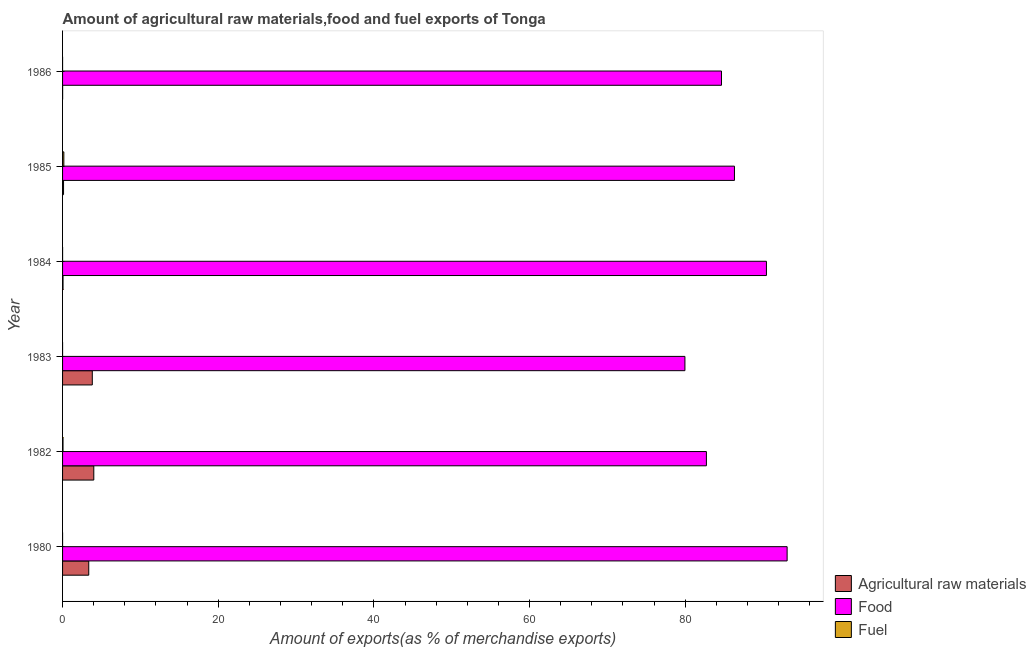Are the number of bars on each tick of the Y-axis equal?
Ensure brevity in your answer.  Yes. How many bars are there on the 6th tick from the bottom?
Keep it short and to the point. 3. In how many cases, is the number of bars for a given year not equal to the number of legend labels?
Offer a very short reply. 0. What is the percentage of fuel exports in 1984?
Provide a succinct answer. 0. Across all years, what is the maximum percentage of fuel exports?
Keep it short and to the point. 0.16. Across all years, what is the minimum percentage of food exports?
Ensure brevity in your answer.  79.96. What is the total percentage of fuel exports in the graph?
Make the answer very short. 0.22. What is the difference between the percentage of food exports in 1982 and that in 1984?
Give a very brief answer. -7.71. What is the difference between the percentage of fuel exports in 1985 and the percentage of raw materials exports in 1986?
Make the answer very short. 0.16. What is the average percentage of food exports per year?
Offer a terse response. 86.19. In the year 1983, what is the difference between the percentage of fuel exports and percentage of raw materials exports?
Your answer should be very brief. -3.82. In how many years, is the percentage of food exports greater than 40 %?
Give a very brief answer. 6. What is the ratio of the percentage of fuel exports in 1982 to that in 1986?
Provide a short and direct response. 410.56. Is the difference between the percentage of fuel exports in 1983 and 1985 greater than the difference between the percentage of raw materials exports in 1983 and 1985?
Make the answer very short. No. What is the difference between the highest and the second highest percentage of fuel exports?
Provide a succinct answer. 0.11. What is the difference between the highest and the lowest percentage of food exports?
Give a very brief answer. 13.13. Is the sum of the percentage of food exports in 1983 and 1986 greater than the maximum percentage of raw materials exports across all years?
Keep it short and to the point. Yes. What does the 2nd bar from the top in 1982 represents?
Offer a very short reply. Food. What does the 1st bar from the bottom in 1980 represents?
Your answer should be compact. Agricultural raw materials. Is it the case that in every year, the sum of the percentage of raw materials exports and percentage of food exports is greater than the percentage of fuel exports?
Keep it short and to the point. Yes. How many bars are there?
Your answer should be very brief. 18. What is the difference between two consecutive major ticks on the X-axis?
Your response must be concise. 20. Does the graph contain any zero values?
Make the answer very short. No. How are the legend labels stacked?
Your response must be concise. Vertical. What is the title of the graph?
Your answer should be very brief. Amount of agricultural raw materials,food and fuel exports of Tonga. What is the label or title of the X-axis?
Keep it short and to the point. Amount of exports(as % of merchandise exports). What is the label or title of the Y-axis?
Provide a short and direct response. Year. What is the Amount of exports(as % of merchandise exports) in Agricultural raw materials in 1980?
Ensure brevity in your answer.  3.36. What is the Amount of exports(as % of merchandise exports) in Food in 1980?
Your answer should be very brief. 93.09. What is the Amount of exports(as % of merchandise exports) in Fuel in 1980?
Give a very brief answer. 0. What is the Amount of exports(as % of merchandise exports) in Agricultural raw materials in 1982?
Keep it short and to the point. 4.01. What is the Amount of exports(as % of merchandise exports) of Food in 1982?
Your response must be concise. 82.72. What is the Amount of exports(as % of merchandise exports) in Fuel in 1982?
Your answer should be very brief. 0.06. What is the Amount of exports(as % of merchandise exports) of Agricultural raw materials in 1983?
Give a very brief answer. 3.82. What is the Amount of exports(as % of merchandise exports) in Food in 1983?
Provide a short and direct response. 79.96. What is the Amount of exports(as % of merchandise exports) of Fuel in 1983?
Give a very brief answer. 0. What is the Amount of exports(as % of merchandise exports) of Agricultural raw materials in 1984?
Make the answer very short. 0.06. What is the Amount of exports(as % of merchandise exports) of Food in 1984?
Provide a succinct answer. 90.43. What is the Amount of exports(as % of merchandise exports) in Fuel in 1984?
Ensure brevity in your answer.  0. What is the Amount of exports(as % of merchandise exports) in Agricultural raw materials in 1985?
Ensure brevity in your answer.  0.13. What is the Amount of exports(as % of merchandise exports) in Food in 1985?
Ensure brevity in your answer.  86.32. What is the Amount of exports(as % of merchandise exports) in Fuel in 1985?
Make the answer very short. 0.16. What is the Amount of exports(as % of merchandise exports) in Agricultural raw materials in 1986?
Ensure brevity in your answer.  0.01. What is the Amount of exports(as % of merchandise exports) in Food in 1986?
Make the answer very short. 84.65. What is the Amount of exports(as % of merchandise exports) in Fuel in 1986?
Your answer should be very brief. 0. Across all years, what is the maximum Amount of exports(as % of merchandise exports) of Agricultural raw materials?
Offer a terse response. 4.01. Across all years, what is the maximum Amount of exports(as % of merchandise exports) of Food?
Make the answer very short. 93.09. Across all years, what is the maximum Amount of exports(as % of merchandise exports) in Fuel?
Your answer should be very brief. 0.16. Across all years, what is the minimum Amount of exports(as % of merchandise exports) in Agricultural raw materials?
Give a very brief answer. 0.01. Across all years, what is the minimum Amount of exports(as % of merchandise exports) of Food?
Offer a terse response. 79.96. Across all years, what is the minimum Amount of exports(as % of merchandise exports) of Fuel?
Your answer should be compact. 0. What is the total Amount of exports(as % of merchandise exports) in Agricultural raw materials in the graph?
Keep it short and to the point. 11.39. What is the total Amount of exports(as % of merchandise exports) in Food in the graph?
Provide a succinct answer. 517.17. What is the total Amount of exports(as % of merchandise exports) in Fuel in the graph?
Ensure brevity in your answer.  0.22. What is the difference between the Amount of exports(as % of merchandise exports) in Agricultural raw materials in 1980 and that in 1982?
Provide a succinct answer. -0.65. What is the difference between the Amount of exports(as % of merchandise exports) in Food in 1980 and that in 1982?
Provide a succinct answer. 10.37. What is the difference between the Amount of exports(as % of merchandise exports) of Fuel in 1980 and that in 1982?
Your response must be concise. -0.06. What is the difference between the Amount of exports(as % of merchandise exports) of Agricultural raw materials in 1980 and that in 1983?
Make the answer very short. -0.46. What is the difference between the Amount of exports(as % of merchandise exports) of Food in 1980 and that in 1983?
Your response must be concise. 13.13. What is the difference between the Amount of exports(as % of merchandise exports) of Fuel in 1980 and that in 1983?
Give a very brief answer. -0. What is the difference between the Amount of exports(as % of merchandise exports) in Agricultural raw materials in 1980 and that in 1984?
Offer a terse response. 3.3. What is the difference between the Amount of exports(as % of merchandise exports) in Food in 1980 and that in 1984?
Give a very brief answer. 2.66. What is the difference between the Amount of exports(as % of merchandise exports) of Fuel in 1980 and that in 1984?
Give a very brief answer. -0. What is the difference between the Amount of exports(as % of merchandise exports) of Agricultural raw materials in 1980 and that in 1985?
Provide a short and direct response. 3.24. What is the difference between the Amount of exports(as % of merchandise exports) in Food in 1980 and that in 1985?
Give a very brief answer. 6.77. What is the difference between the Amount of exports(as % of merchandise exports) of Fuel in 1980 and that in 1985?
Provide a succinct answer. -0.16. What is the difference between the Amount of exports(as % of merchandise exports) in Agricultural raw materials in 1980 and that in 1986?
Ensure brevity in your answer.  3.36. What is the difference between the Amount of exports(as % of merchandise exports) of Food in 1980 and that in 1986?
Keep it short and to the point. 8.43. What is the difference between the Amount of exports(as % of merchandise exports) of Agricultural raw materials in 1982 and that in 1983?
Keep it short and to the point. 0.19. What is the difference between the Amount of exports(as % of merchandise exports) of Food in 1982 and that in 1983?
Make the answer very short. 2.76. What is the difference between the Amount of exports(as % of merchandise exports) in Fuel in 1982 and that in 1983?
Ensure brevity in your answer.  0.06. What is the difference between the Amount of exports(as % of merchandise exports) in Agricultural raw materials in 1982 and that in 1984?
Provide a succinct answer. 3.95. What is the difference between the Amount of exports(as % of merchandise exports) in Food in 1982 and that in 1984?
Ensure brevity in your answer.  -7.71. What is the difference between the Amount of exports(as % of merchandise exports) in Fuel in 1982 and that in 1984?
Provide a short and direct response. 0.06. What is the difference between the Amount of exports(as % of merchandise exports) of Agricultural raw materials in 1982 and that in 1985?
Keep it short and to the point. 3.89. What is the difference between the Amount of exports(as % of merchandise exports) in Food in 1982 and that in 1985?
Offer a terse response. -3.6. What is the difference between the Amount of exports(as % of merchandise exports) of Fuel in 1982 and that in 1985?
Keep it short and to the point. -0.11. What is the difference between the Amount of exports(as % of merchandise exports) in Agricultural raw materials in 1982 and that in 1986?
Provide a succinct answer. 4. What is the difference between the Amount of exports(as % of merchandise exports) in Food in 1982 and that in 1986?
Make the answer very short. -1.94. What is the difference between the Amount of exports(as % of merchandise exports) in Fuel in 1982 and that in 1986?
Your answer should be very brief. 0.06. What is the difference between the Amount of exports(as % of merchandise exports) in Agricultural raw materials in 1983 and that in 1984?
Ensure brevity in your answer.  3.76. What is the difference between the Amount of exports(as % of merchandise exports) of Food in 1983 and that in 1984?
Your response must be concise. -10.47. What is the difference between the Amount of exports(as % of merchandise exports) in Fuel in 1983 and that in 1984?
Provide a succinct answer. -0. What is the difference between the Amount of exports(as % of merchandise exports) in Agricultural raw materials in 1983 and that in 1985?
Give a very brief answer. 3.7. What is the difference between the Amount of exports(as % of merchandise exports) of Food in 1983 and that in 1985?
Your response must be concise. -6.36. What is the difference between the Amount of exports(as % of merchandise exports) of Fuel in 1983 and that in 1985?
Provide a succinct answer. -0.16. What is the difference between the Amount of exports(as % of merchandise exports) in Agricultural raw materials in 1983 and that in 1986?
Your answer should be very brief. 3.81. What is the difference between the Amount of exports(as % of merchandise exports) of Food in 1983 and that in 1986?
Ensure brevity in your answer.  -4.7. What is the difference between the Amount of exports(as % of merchandise exports) of Agricultural raw materials in 1984 and that in 1985?
Your answer should be very brief. -0.07. What is the difference between the Amount of exports(as % of merchandise exports) in Food in 1984 and that in 1985?
Provide a succinct answer. 4.11. What is the difference between the Amount of exports(as % of merchandise exports) of Fuel in 1984 and that in 1985?
Provide a succinct answer. -0.16. What is the difference between the Amount of exports(as % of merchandise exports) in Agricultural raw materials in 1984 and that in 1986?
Provide a succinct answer. 0.05. What is the difference between the Amount of exports(as % of merchandise exports) in Food in 1984 and that in 1986?
Your answer should be very brief. 5.78. What is the difference between the Amount of exports(as % of merchandise exports) in Fuel in 1984 and that in 1986?
Keep it short and to the point. 0. What is the difference between the Amount of exports(as % of merchandise exports) in Agricultural raw materials in 1985 and that in 1986?
Make the answer very short. 0.12. What is the difference between the Amount of exports(as % of merchandise exports) of Food in 1985 and that in 1986?
Your response must be concise. 1.67. What is the difference between the Amount of exports(as % of merchandise exports) of Fuel in 1985 and that in 1986?
Ensure brevity in your answer.  0.16. What is the difference between the Amount of exports(as % of merchandise exports) in Agricultural raw materials in 1980 and the Amount of exports(as % of merchandise exports) in Food in 1982?
Your answer should be compact. -79.35. What is the difference between the Amount of exports(as % of merchandise exports) in Agricultural raw materials in 1980 and the Amount of exports(as % of merchandise exports) in Fuel in 1982?
Offer a terse response. 3.31. What is the difference between the Amount of exports(as % of merchandise exports) of Food in 1980 and the Amount of exports(as % of merchandise exports) of Fuel in 1982?
Provide a short and direct response. 93.03. What is the difference between the Amount of exports(as % of merchandise exports) in Agricultural raw materials in 1980 and the Amount of exports(as % of merchandise exports) in Food in 1983?
Provide a succinct answer. -76.59. What is the difference between the Amount of exports(as % of merchandise exports) of Agricultural raw materials in 1980 and the Amount of exports(as % of merchandise exports) of Fuel in 1983?
Make the answer very short. 3.36. What is the difference between the Amount of exports(as % of merchandise exports) in Food in 1980 and the Amount of exports(as % of merchandise exports) in Fuel in 1983?
Offer a terse response. 93.09. What is the difference between the Amount of exports(as % of merchandise exports) in Agricultural raw materials in 1980 and the Amount of exports(as % of merchandise exports) in Food in 1984?
Offer a very short reply. -87.07. What is the difference between the Amount of exports(as % of merchandise exports) in Agricultural raw materials in 1980 and the Amount of exports(as % of merchandise exports) in Fuel in 1984?
Your answer should be very brief. 3.36. What is the difference between the Amount of exports(as % of merchandise exports) in Food in 1980 and the Amount of exports(as % of merchandise exports) in Fuel in 1984?
Keep it short and to the point. 93.09. What is the difference between the Amount of exports(as % of merchandise exports) in Agricultural raw materials in 1980 and the Amount of exports(as % of merchandise exports) in Food in 1985?
Your answer should be compact. -82.96. What is the difference between the Amount of exports(as % of merchandise exports) in Agricultural raw materials in 1980 and the Amount of exports(as % of merchandise exports) in Fuel in 1985?
Your answer should be very brief. 3.2. What is the difference between the Amount of exports(as % of merchandise exports) in Food in 1980 and the Amount of exports(as % of merchandise exports) in Fuel in 1985?
Provide a short and direct response. 92.92. What is the difference between the Amount of exports(as % of merchandise exports) of Agricultural raw materials in 1980 and the Amount of exports(as % of merchandise exports) of Food in 1986?
Offer a very short reply. -81.29. What is the difference between the Amount of exports(as % of merchandise exports) in Agricultural raw materials in 1980 and the Amount of exports(as % of merchandise exports) in Fuel in 1986?
Offer a very short reply. 3.36. What is the difference between the Amount of exports(as % of merchandise exports) of Food in 1980 and the Amount of exports(as % of merchandise exports) of Fuel in 1986?
Your answer should be compact. 93.09. What is the difference between the Amount of exports(as % of merchandise exports) in Agricultural raw materials in 1982 and the Amount of exports(as % of merchandise exports) in Food in 1983?
Ensure brevity in your answer.  -75.95. What is the difference between the Amount of exports(as % of merchandise exports) in Agricultural raw materials in 1982 and the Amount of exports(as % of merchandise exports) in Fuel in 1983?
Offer a terse response. 4.01. What is the difference between the Amount of exports(as % of merchandise exports) of Food in 1982 and the Amount of exports(as % of merchandise exports) of Fuel in 1983?
Your answer should be very brief. 82.72. What is the difference between the Amount of exports(as % of merchandise exports) in Agricultural raw materials in 1982 and the Amount of exports(as % of merchandise exports) in Food in 1984?
Offer a terse response. -86.42. What is the difference between the Amount of exports(as % of merchandise exports) in Agricultural raw materials in 1982 and the Amount of exports(as % of merchandise exports) in Fuel in 1984?
Your response must be concise. 4.01. What is the difference between the Amount of exports(as % of merchandise exports) of Food in 1982 and the Amount of exports(as % of merchandise exports) of Fuel in 1984?
Offer a terse response. 82.72. What is the difference between the Amount of exports(as % of merchandise exports) of Agricultural raw materials in 1982 and the Amount of exports(as % of merchandise exports) of Food in 1985?
Provide a succinct answer. -82.31. What is the difference between the Amount of exports(as % of merchandise exports) of Agricultural raw materials in 1982 and the Amount of exports(as % of merchandise exports) of Fuel in 1985?
Offer a terse response. 3.85. What is the difference between the Amount of exports(as % of merchandise exports) in Food in 1982 and the Amount of exports(as % of merchandise exports) in Fuel in 1985?
Make the answer very short. 82.55. What is the difference between the Amount of exports(as % of merchandise exports) in Agricultural raw materials in 1982 and the Amount of exports(as % of merchandise exports) in Food in 1986?
Offer a very short reply. -80.64. What is the difference between the Amount of exports(as % of merchandise exports) of Agricultural raw materials in 1982 and the Amount of exports(as % of merchandise exports) of Fuel in 1986?
Offer a very short reply. 4.01. What is the difference between the Amount of exports(as % of merchandise exports) of Food in 1982 and the Amount of exports(as % of merchandise exports) of Fuel in 1986?
Keep it short and to the point. 82.72. What is the difference between the Amount of exports(as % of merchandise exports) of Agricultural raw materials in 1983 and the Amount of exports(as % of merchandise exports) of Food in 1984?
Your answer should be compact. -86.61. What is the difference between the Amount of exports(as % of merchandise exports) of Agricultural raw materials in 1983 and the Amount of exports(as % of merchandise exports) of Fuel in 1984?
Your answer should be compact. 3.82. What is the difference between the Amount of exports(as % of merchandise exports) in Food in 1983 and the Amount of exports(as % of merchandise exports) in Fuel in 1984?
Ensure brevity in your answer.  79.96. What is the difference between the Amount of exports(as % of merchandise exports) in Agricultural raw materials in 1983 and the Amount of exports(as % of merchandise exports) in Food in 1985?
Ensure brevity in your answer.  -82.5. What is the difference between the Amount of exports(as % of merchandise exports) of Agricultural raw materials in 1983 and the Amount of exports(as % of merchandise exports) of Fuel in 1985?
Your answer should be very brief. 3.66. What is the difference between the Amount of exports(as % of merchandise exports) of Food in 1983 and the Amount of exports(as % of merchandise exports) of Fuel in 1985?
Your answer should be very brief. 79.79. What is the difference between the Amount of exports(as % of merchandise exports) of Agricultural raw materials in 1983 and the Amount of exports(as % of merchandise exports) of Food in 1986?
Provide a short and direct response. -80.83. What is the difference between the Amount of exports(as % of merchandise exports) in Agricultural raw materials in 1983 and the Amount of exports(as % of merchandise exports) in Fuel in 1986?
Provide a short and direct response. 3.82. What is the difference between the Amount of exports(as % of merchandise exports) of Food in 1983 and the Amount of exports(as % of merchandise exports) of Fuel in 1986?
Offer a terse response. 79.96. What is the difference between the Amount of exports(as % of merchandise exports) in Agricultural raw materials in 1984 and the Amount of exports(as % of merchandise exports) in Food in 1985?
Make the answer very short. -86.26. What is the difference between the Amount of exports(as % of merchandise exports) of Agricultural raw materials in 1984 and the Amount of exports(as % of merchandise exports) of Fuel in 1985?
Ensure brevity in your answer.  -0.1. What is the difference between the Amount of exports(as % of merchandise exports) of Food in 1984 and the Amount of exports(as % of merchandise exports) of Fuel in 1985?
Offer a terse response. 90.27. What is the difference between the Amount of exports(as % of merchandise exports) in Agricultural raw materials in 1984 and the Amount of exports(as % of merchandise exports) in Food in 1986?
Give a very brief answer. -84.6. What is the difference between the Amount of exports(as % of merchandise exports) in Agricultural raw materials in 1984 and the Amount of exports(as % of merchandise exports) in Fuel in 1986?
Give a very brief answer. 0.06. What is the difference between the Amount of exports(as % of merchandise exports) in Food in 1984 and the Amount of exports(as % of merchandise exports) in Fuel in 1986?
Make the answer very short. 90.43. What is the difference between the Amount of exports(as % of merchandise exports) in Agricultural raw materials in 1985 and the Amount of exports(as % of merchandise exports) in Food in 1986?
Your answer should be very brief. -84.53. What is the difference between the Amount of exports(as % of merchandise exports) in Agricultural raw materials in 1985 and the Amount of exports(as % of merchandise exports) in Fuel in 1986?
Make the answer very short. 0.13. What is the difference between the Amount of exports(as % of merchandise exports) of Food in 1985 and the Amount of exports(as % of merchandise exports) of Fuel in 1986?
Make the answer very short. 86.32. What is the average Amount of exports(as % of merchandise exports) of Agricultural raw materials per year?
Give a very brief answer. 1.9. What is the average Amount of exports(as % of merchandise exports) of Food per year?
Ensure brevity in your answer.  86.19. What is the average Amount of exports(as % of merchandise exports) of Fuel per year?
Offer a very short reply. 0.04. In the year 1980, what is the difference between the Amount of exports(as % of merchandise exports) in Agricultural raw materials and Amount of exports(as % of merchandise exports) in Food?
Give a very brief answer. -89.72. In the year 1980, what is the difference between the Amount of exports(as % of merchandise exports) in Agricultural raw materials and Amount of exports(as % of merchandise exports) in Fuel?
Give a very brief answer. 3.36. In the year 1980, what is the difference between the Amount of exports(as % of merchandise exports) of Food and Amount of exports(as % of merchandise exports) of Fuel?
Give a very brief answer. 93.09. In the year 1982, what is the difference between the Amount of exports(as % of merchandise exports) of Agricultural raw materials and Amount of exports(as % of merchandise exports) of Food?
Make the answer very short. -78.71. In the year 1982, what is the difference between the Amount of exports(as % of merchandise exports) of Agricultural raw materials and Amount of exports(as % of merchandise exports) of Fuel?
Ensure brevity in your answer.  3.95. In the year 1982, what is the difference between the Amount of exports(as % of merchandise exports) of Food and Amount of exports(as % of merchandise exports) of Fuel?
Keep it short and to the point. 82.66. In the year 1983, what is the difference between the Amount of exports(as % of merchandise exports) in Agricultural raw materials and Amount of exports(as % of merchandise exports) in Food?
Your answer should be very brief. -76.14. In the year 1983, what is the difference between the Amount of exports(as % of merchandise exports) of Agricultural raw materials and Amount of exports(as % of merchandise exports) of Fuel?
Provide a short and direct response. 3.82. In the year 1983, what is the difference between the Amount of exports(as % of merchandise exports) in Food and Amount of exports(as % of merchandise exports) in Fuel?
Provide a succinct answer. 79.96. In the year 1984, what is the difference between the Amount of exports(as % of merchandise exports) in Agricultural raw materials and Amount of exports(as % of merchandise exports) in Food?
Make the answer very short. -90.37. In the year 1984, what is the difference between the Amount of exports(as % of merchandise exports) in Agricultural raw materials and Amount of exports(as % of merchandise exports) in Fuel?
Provide a short and direct response. 0.06. In the year 1984, what is the difference between the Amount of exports(as % of merchandise exports) in Food and Amount of exports(as % of merchandise exports) in Fuel?
Provide a short and direct response. 90.43. In the year 1985, what is the difference between the Amount of exports(as % of merchandise exports) of Agricultural raw materials and Amount of exports(as % of merchandise exports) of Food?
Your answer should be very brief. -86.2. In the year 1985, what is the difference between the Amount of exports(as % of merchandise exports) in Agricultural raw materials and Amount of exports(as % of merchandise exports) in Fuel?
Offer a terse response. -0.04. In the year 1985, what is the difference between the Amount of exports(as % of merchandise exports) of Food and Amount of exports(as % of merchandise exports) of Fuel?
Your answer should be very brief. 86.16. In the year 1986, what is the difference between the Amount of exports(as % of merchandise exports) of Agricultural raw materials and Amount of exports(as % of merchandise exports) of Food?
Give a very brief answer. -84.65. In the year 1986, what is the difference between the Amount of exports(as % of merchandise exports) of Agricultural raw materials and Amount of exports(as % of merchandise exports) of Fuel?
Provide a succinct answer. 0.01. In the year 1986, what is the difference between the Amount of exports(as % of merchandise exports) in Food and Amount of exports(as % of merchandise exports) in Fuel?
Keep it short and to the point. 84.65. What is the ratio of the Amount of exports(as % of merchandise exports) of Agricultural raw materials in 1980 to that in 1982?
Your response must be concise. 0.84. What is the ratio of the Amount of exports(as % of merchandise exports) in Food in 1980 to that in 1982?
Keep it short and to the point. 1.13. What is the ratio of the Amount of exports(as % of merchandise exports) of Fuel in 1980 to that in 1982?
Provide a succinct answer. 0. What is the ratio of the Amount of exports(as % of merchandise exports) of Agricultural raw materials in 1980 to that in 1983?
Offer a very short reply. 0.88. What is the ratio of the Amount of exports(as % of merchandise exports) of Food in 1980 to that in 1983?
Provide a succinct answer. 1.16. What is the ratio of the Amount of exports(as % of merchandise exports) in Fuel in 1980 to that in 1983?
Make the answer very short. 0.48. What is the ratio of the Amount of exports(as % of merchandise exports) in Agricultural raw materials in 1980 to that in 1984?
Provide a short and direct response. 56.45. What is the ratio of the Amount of exports(as % of merchandise exports) in Food in 1980 to that in 1984?
Your response must be concise. 1.03. What is the ratio of the Amount of exports(as % of merchandise exports) in Fuel in 1980 to that in 1984?
Provide a short and direct response. 0.24. What is the ratio of the Amount of exports(as % of merchandise exports) of Agricultural raw materials in 1980 to that in 1985?
Make the answer very short. 26.84. What is the ratio of the Amount of exports(as % of merchandise exports) in Food in 1980 to that in 1985?
Offer a terse response. 1.08. What is the ratio of the Amount of exports(as % of merchandise exports) of Fuel in 1980 to that in 1985?
Your answer should be compact. 0. What is the ratio of the Amount of exports(as % of merchandise exports) in Agricultural raw materials in 1980 to that in 1986?
Your response must be concise. 396.72. What is the ratio of the Amount of exports(as % of merchandise exports) of Food in 1980 to that in 1986?
Your answer should be very brief. 1.1. What is the ratio of the Amount of exports(as % of merchandise exports) of Fuel in 1980 to that in 1986?
Make the answer very short. 1.08. What is the ratio of the Amount of exports(as % of merchandise exports) in Agricultural raw materials in 1982 to that in 1983?
Offer a very short reply. 1.05. What is the ratio of the Amount of exports(as % of merchandise exports) of Food in 1982 to that in 1983?
Ensure brevity in your answer.  1.03. What is the ratio of the Amount of exports(as % of merchandise exports) of Fuel in 1982 to that in 1983?
Make the answer very short. 183.45. What is the ratio of the Amount of exports(as % of merchandise exports) of Agricultural raw materials in 1982 to that in 1984?
Offer a terse response. 67.31. What is the ratio of the Amount of exports(as % of merchandise exports) in Food in 1982 to that in 1984?
Ensure brevity in your answer.  0.91. What is the ratio of the Amount of exports(as % of merchandise exports) in Fuel in 1982 to that in 1984?
Ensure brevity in your answer.  92.06. What is the ratio of the Amount of exports(as % of merchandise exports) in Agricultural raw materials in 1982 to that in 1985?
Ensure brevity in your answer.  32.01. What is the ratio of the Amount of exports(as % of merchandise exports) of Fuel in 1982 to that in 1985?
Ensure brevity in your answer.  0.35. What is the ratio of the Amount of exports(as % of merchandise exports) in Agricultural raw materials in 1982 to that in 1986?
Your answer should be compact. 473.09. What is the ratio of the Amount of exports(as % of merchandise exports) of Food in 1982 to that in 1986?
Your response must be concise. 0.98. What is the ratio of the Amount of exports(as % of merchandise exports) in Fuel in 1982 to that in 1986?
Your response must be concise. 410.56. What is the ratio of the Amount of exports(as % of merchandise exports) in Agricultural raw materials in 1983 to that in 1984?
Offer a very short reply. 64.1. What is the ratio of the Amount of exports(as % of merchandise exports) in Food in 1983 to that in 1984?
Provide a succinct answer. 0.88. What is the ratio of the Amount of exports(as % of merchandise exports) in Fuel in 1983 to that in 1984?
Ensure brevity in your answer.  0.5. What is the ratio of the Amount of exports(as % of merchandise exports) in Agricultural raw materials in 1983 to that in 1985?
Your response must be concise. 30.48. What is the ratio of the Amount of exports(as % of merchandise exports) of Food in 1983 to that in 1985?
Provide a short and direct response. 0.93. What is the ratio of the Amount of exports(as % of merchandise exports) in Fuel in 1983 to that in 1985?
Give a very brief answer. 0. What is the ratio of the Amount of exports(as % of merchandise exports) of Agricultural raw materials in 1983 to that in 1986?
Make the answer very short. 450.52. What is the ratio of the Amount of exports(as % of merchandise exports) of Food in 1983 to that in 1986?
Your answer should be very brief. 0.94. What is the ratio of the Amount of exports(as % of merchandise exports) of Fuel in 1983 to that in 1986?
Provide a succinct answer. 2.24. What is the ratio of the Amount of exports(as % of merchandise exports) of Agricultural raw materials in 1984 to that in 1985?
Keep it short and to the point. 0.48. What is the ratio of the Amount of exports(as % of merchandise exports) of Food in 1984 to that in 1985?
Your answer should be very brief. 1.05. What is the ratio of the Amount of exports(as % of merchandise exports) of Fuel in 1984 to that in 1985?
Your answer should be very brief. 0. What is the ratio of the Amount of exports(as % of merchandise exports) in Agricultural raw materials in 1984 to that in 1986?
Make the answer very short. 7.03. What is the ratio of the Amount of exports(as % of merchandise exports) of Food in 1984 to that in 1986?
Your answer should be very brief. 1.07. What is the ratio of the Amount of exports(as % of merchandise exports) in Fuel in 1984 to that in 1986?
Provide a short and direct response. 4.46. What is the ratio of the Amount of exports(as % of merchandise exports) of Agricultural raw materials in 1985 to that in 1986?
Offer a terse response. 14.78. What is the ratio of the Amount of exports(as % of merchandise exports) of Food in 1985 to that in 1986?
Make the answer very short. 1.02. What is the ratio of the Amount of exports(as % of merchandise exports) in Fuel in 1985 to that in 1986?
Ensure brevity in your answer.  1167.45. What is the difference between the highest and the second highest Amount of exports(as % of merchandise exports) of Agricultural raw materials?
Provide a short and direct response. 0.19. What is the difference between the highest and the second highest Amount of exports(as % of merchandise exports) in Food?
Give a very brief answer. 2.66. What is the difference between the highest and the second highest Amount of exports(as % of merchandise exports) of Fuel?
Offer a terse response. 0.11. What is the difference between the highest and the lowest Amount of exports(as % of merchandise exports) in Agricultural raw materials?
Offer a terse response. 4. What is the difference between the highest and the lowest Amount of exports(as % of merchandise exports) in Food?
Keep it short and to the point. 13.13. What is the difference between the highest and the lowest Amount of exports(as % of merchandise exports) of Fuel?
Your answer should be compact. 0.16. 